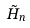Convert formula to latex. <formula><loc_0><loc_0><loc_500><loc_500>\tilde { H } _ { n }</formula> 